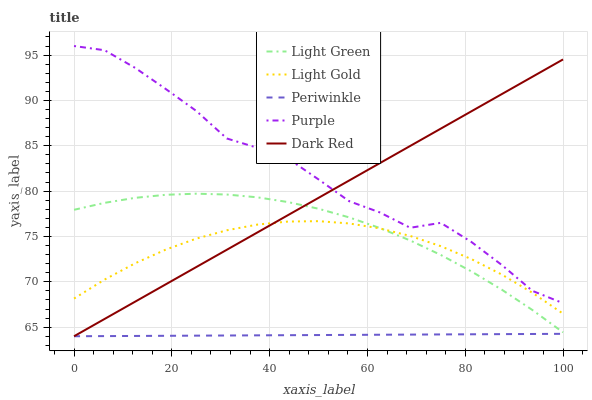Does Periwinkle have the minimum area under the curve?
Answer yes or no. Yes. Does Purple have the maximum area under the curve?
Answer yes or no. Yes. Does Light Gold have the minimum area under the curve?
Answer yes or no. No. Does Light Gold have the maximum area under the curve?
Answer yes or no. No. Is Periwinkle the smoothest?
Answer yes or no. Yes. Is Purple the roughest?
Answer yes or no. Yes. Is Light Gold the smoothest?
Answer yes or no. No. Is Light Gold the roughest?
Answer yes or no. No. Does Periwinkle have the lowest value?
Answer yes or no. Yes. Does Light Gold have the lowest value?
Answer yes or no. No. Does Purple have the highest value?
Answer yes or no. Yes. Does Light Gold have the highest value?
Answer yes or no. No. Is Periwinkle less than Light Gold?
Answer yes or no. Yes. Is Light Green greater than Periwinkle?
Answer yes or no. Yes. Does Purple intersect Dark Red?
Answer yes or no. Yes. Is Purple less than Dark Red?
Answer yes or no. No. Is Purple greater than Dark Red?
Answer yes or no. No. Does Periwinkle intersect Light Gold?
Answer yes or no. No. 